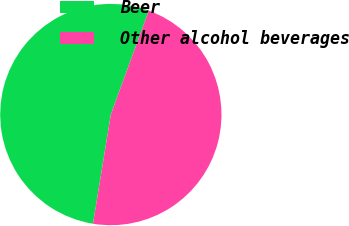Convert chart to OTSL. <chart><loc_0><loc_0><loc_500><loc_500><pie_chart><fcel>Beer<fcel>Other alcohol beverages<nl><fcel>53.0%<fcel>47.0%<nl></chart> 